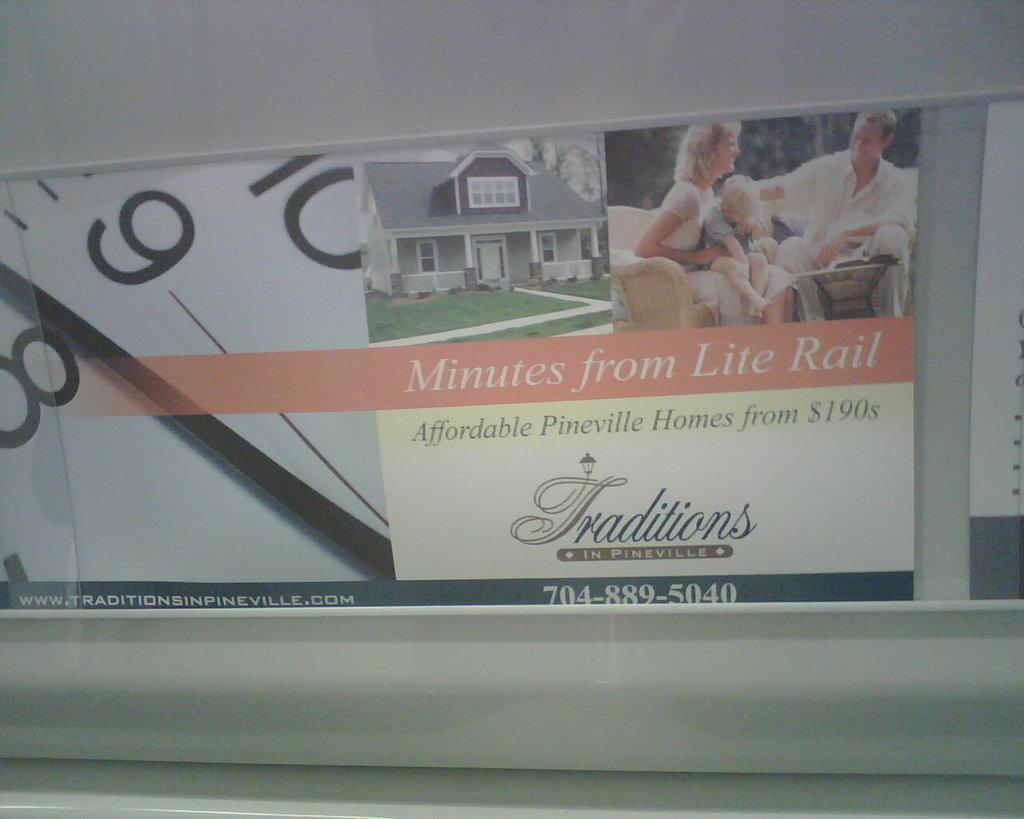What is present on the wall in the image? There is a poster in the image. What can be found on the poster? The poster contains images and text. What is the background of the poster? The wall is visible in the image. What type of bells can be heard ringing in the image? There are no bells present in the image, and therefore no sound can be heard. 